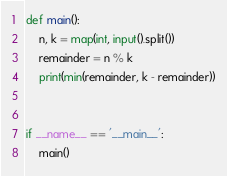Convert code to text. <code><loc_0><loc_0><loc_500><loc_500><_Python_>def main():
    n, k = map(int, input().split())
    remainder = n % k
    print(min(remainder, k - remainder))


if __name__ == '__main__':
    main()

</code> 